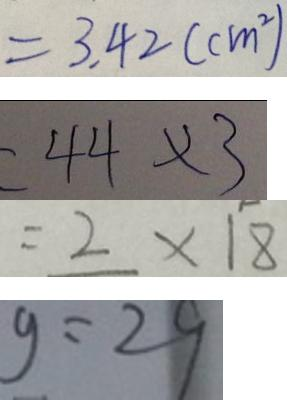Convert formula to latex. <formula><loc_0><loc_0><loc_500><loc_500>= 3 . 4 2 ( c m ^ { 2 } ) 
 = 4 4 \times 3 
 = 2 \times 1 8 
 g = 2 9</formula> 